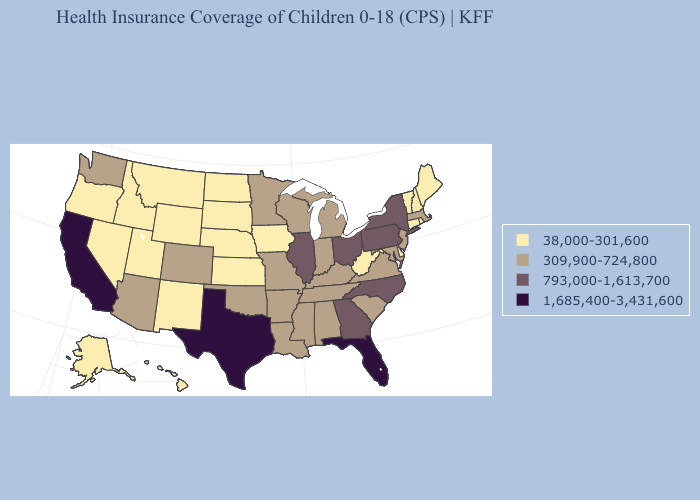Does Rhode Island have the same value as Wyoming?
Short answer required. Yes. Among the states that border Colorado , does Oklahoma have the lowest value?
Quick response, please. No. Does New Mexico have the lowest value in the USA?
Short answer required. Yes. Among the states that border Alabama , does Mississippi have the lowest value?
Quick response, please. Yes. Name the states that have a value in the range 38,000-301,600?
Keep it brief. Alaska, Connecticut, Delaware, Hawaii, Idaho, Iowa, Kansas, Maine, Montana, Nebraska, Nevada, New Hampshire, New Mexico, North Dakota, Oregon, Rhode Island, South Dakota, Utah, Vermont, West Virginia, Wyoming. What is the value of Alaska?
Give a very brief answer. 38,000-301,600. What is the highest value in the Northeast ?
Short answer required. 793,000-1,613,700. Name the states that have a value in the range 38,000-301,600?
Short answer required. Alaska, Connecticut, Delaware, Hawaii, Idaho, Iowa, Kansas, Maine, Montana, Nebraska, Nevada, New Hampshire, New Mexico, North Dakota, Oregon, Rhode Island, South Dakota, Utah, Vermont, West Virginia, Wyoming. Is the legend a continuous bar?
Quick response, please. No. What is the highest value in states that border South Carolina?
Be succinct. 793,000-1,613,700. Is the legend a continuous bar?
Short answer required. No. Does Texas have a lower value than California?
Quick response, please. No. Does North Dakota have the highest value in the MidWest?
Give a very brief answer. No. What is the highest value in states that border North Carolina?
Give a very brief answer. 793,000-1,613,700. Name the states that have a value in the range 38,000-301,600?
Be succinct. Alaska, Connecticut, Delaware, Hawaii, Idaho, Iowa, Kansas, Maine, Montana, Nebraska, Nevada, New Hampshire, New Mexico, North Dakota, Oregon, Rhode Island, South Dakota, Utah, Vermont, West Virginia, Wyoming. 